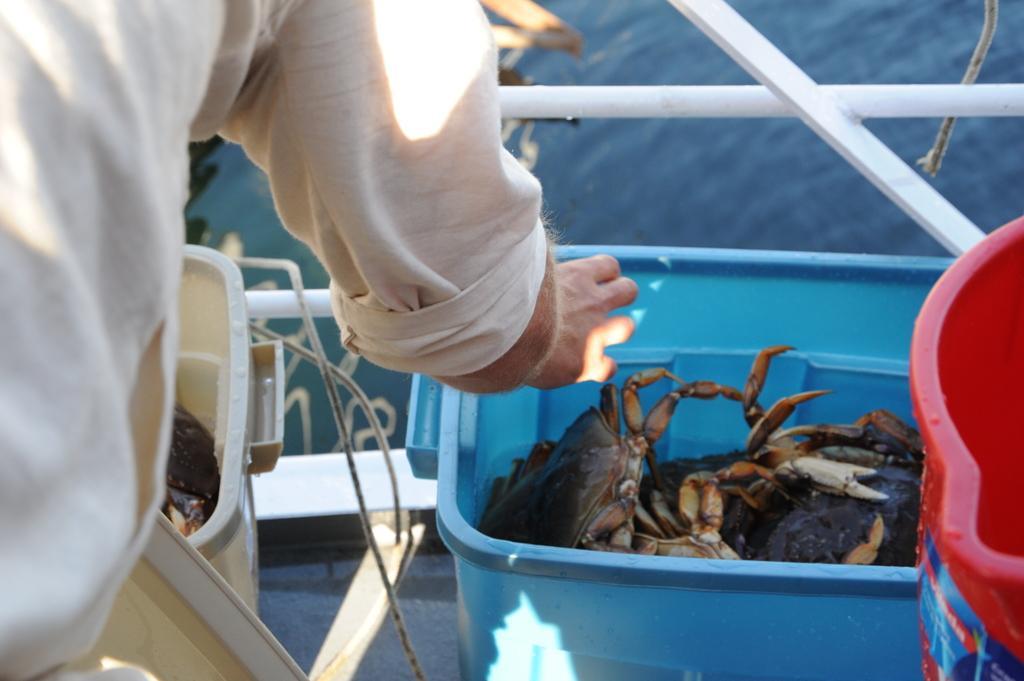Please provide a concise description of this image. In this image there are boxes with crabs, in front of them there is a person standing also there is a water on other side. 